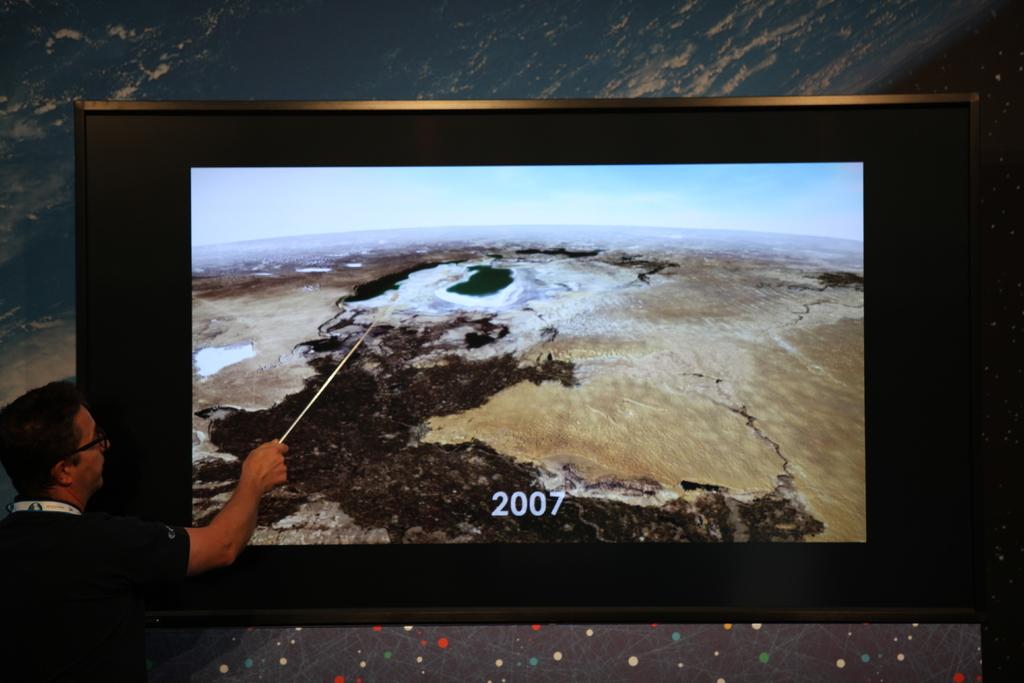What year is this pic?
Your response must be concise. 2007. 